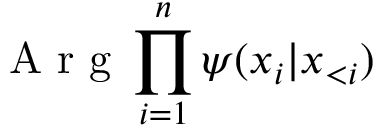Convert formula to latex. <formula><loc_0><loc_0><loc_500><loc_500>A r g \prod _ { i = 1 } ^ { n } \psi ( x _ { i } | x _ { < i } )</formula> 